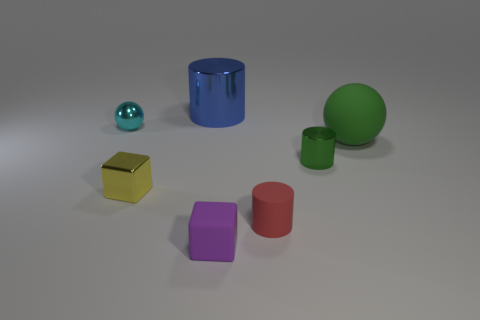There is a big thing that is behind the cyan metallic ball; is it the same shape as the green metallic object?
Provide a short and direct response. Yes. How many green objects are either small rubber things or large metal cylinders?
Your response must be concise. 0. What material is the tiny red object that is the same shape as the tiny green object?
Your answer should be very brief. Rubber. What shape is the tiny shiny object that is right of the blue thing?
Make the answer very short. Cylinder. Is there a cube that has the same material as the small cyan object?
Give a very brief answer. Yes. Do the red cylinder and the green cylinder have the same size?
Ensure brevity in your answer.  Yes. What number of spheres are large things or cyan shiny objects?
Your answer should be very brief. 2. There is a tiny thing that is the same color as the rubber sphere; what is it made of?
Keep it short and to the point. Metal. How many cyan metal things have the same shape as the large green thing?
Keep it short and to the point. 1. Are there more big green rubber balls to the left of the large rubber ball than rubber cubes that are behind the small yellow block?
Ensure brevity in your answer.  No. 